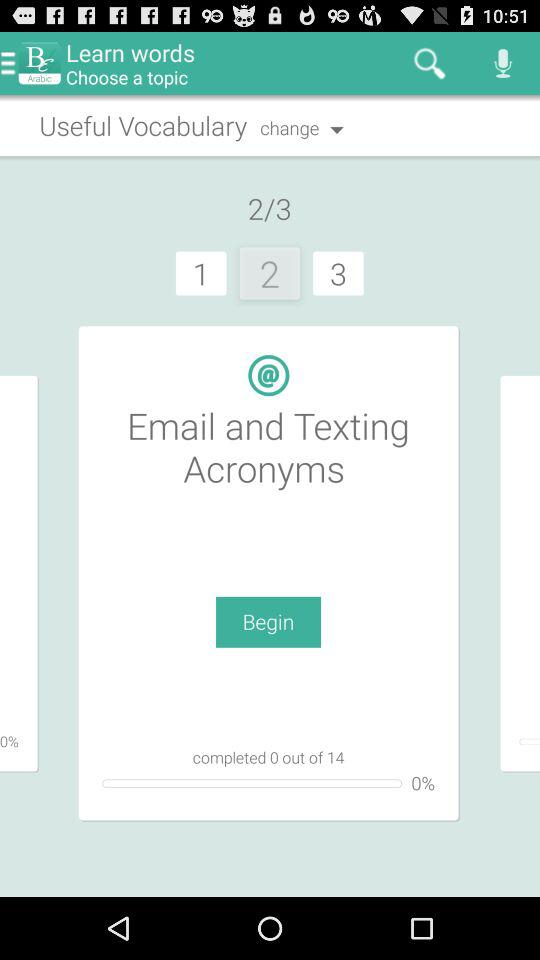How many more lessons are there than completed lessons?
Answer the question using a single word or phrase. 14 